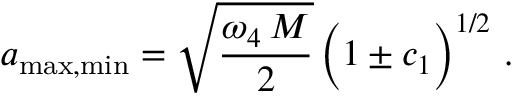Convert formula to latex. <formula><loc_0><loc_0><loc_500><loc_500>a _ { \max , \min } = \sqrt { \frac { \omega _ { 4 } \, M } { 2 } } \, \left ( 1 \pm c _ { 1 } \right ) ^ { 1 / 2 } \, .</formula> 